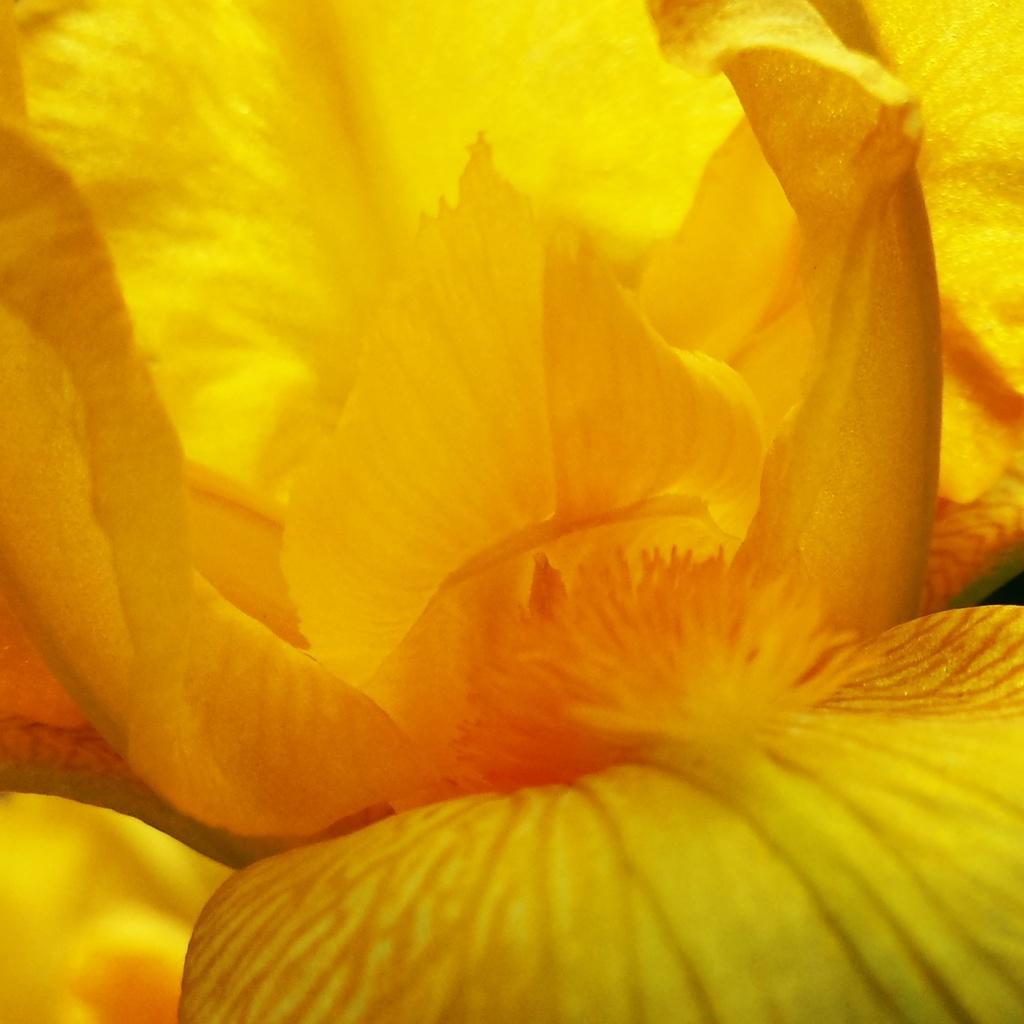What is the main subject of the image? The main subject of the image is a flower. How is the flower presented in the image? The flower is zoomed in the image. What color is the flower? The flower is yellow in color. What type of magic is being performed on the flower in the image? There is no magic being performed on the flower in the image; it is simply a zoomed-in photo of a yellow flower. Can you hear the flower's voice in the image? Flowers do not have voices, so it is not possible to hear the flower's voice in the image. 